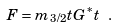<formula> <loc_0><loc_0><loc_500><loc_500>F = m _ { 3 / 2 } t G ^ { * } t \ .</formula> 